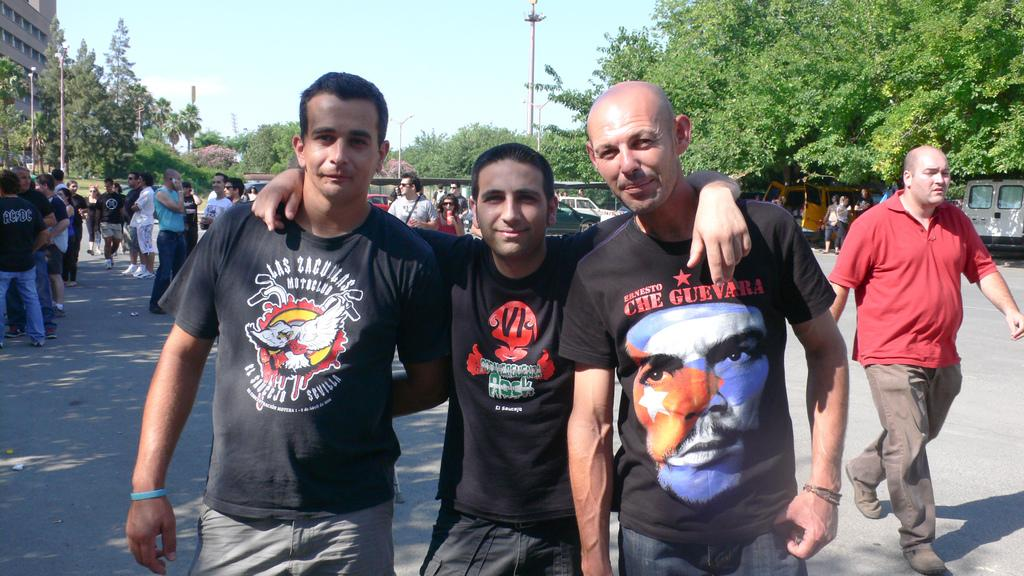How many persons are in the middle of the image? There are three persons in the middle of the image. What is happening on the road in the image? There are people on the road in the image. What objects can be seen in the image besides the people and the road? There are poles, vehicles, plants, trees, and a building visible in the image. What can be seen in the background of the image? The sky is visible in the background of the image. What type of bell can be heard ringing in the image? There is no bell present in the image, and therefore no sound can be heard. 